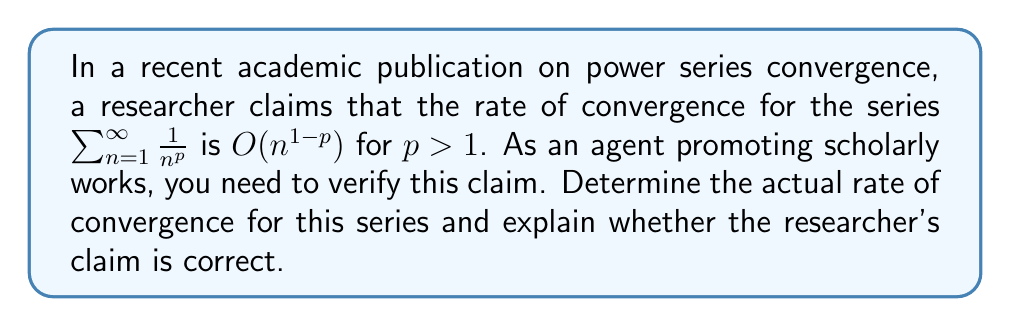Can you answer this question? Let's approach this step-by-step:

1) First, recall that for a series $\sum_{n=1}^{\infty} a_n$, the rate of convergence is typically determined by examining the behavior of the partial sum's error:

   $E_N = \sum_{n=N+1}^{\infty} a_n$

2) In our case, $a_n = \frac{1}{n^p}$, so we need to analyze:

   $E_N = \sum_{n=N+1}^{\infty} \frac{1}{n^p}$

3) We can approximate this sum using an integral:

   $E_N \approx \int_{N}^{\infty} \frac{1}{x^p} dx$

4) Evaluating this integral:

   $\int_{N}^{\infty} \frac{1}{x^p} dx = \left[ \frac{x^{1-p}}{1-p} \right]_{N}^{\infty} = \frac{N^{1-p}}{p-1}$

5) Therefore, $E_N \sim O(N^{1-p})$ for $p > 1$

6) The rate of convergence is the order of $E_N$, which is $O(N^{1-p})$

7) Comparing this to the researcher's claim of $O(n^{1-p})$, we see that the claim is correct.
Answer: $O(N^{1-p})$, claim correct 